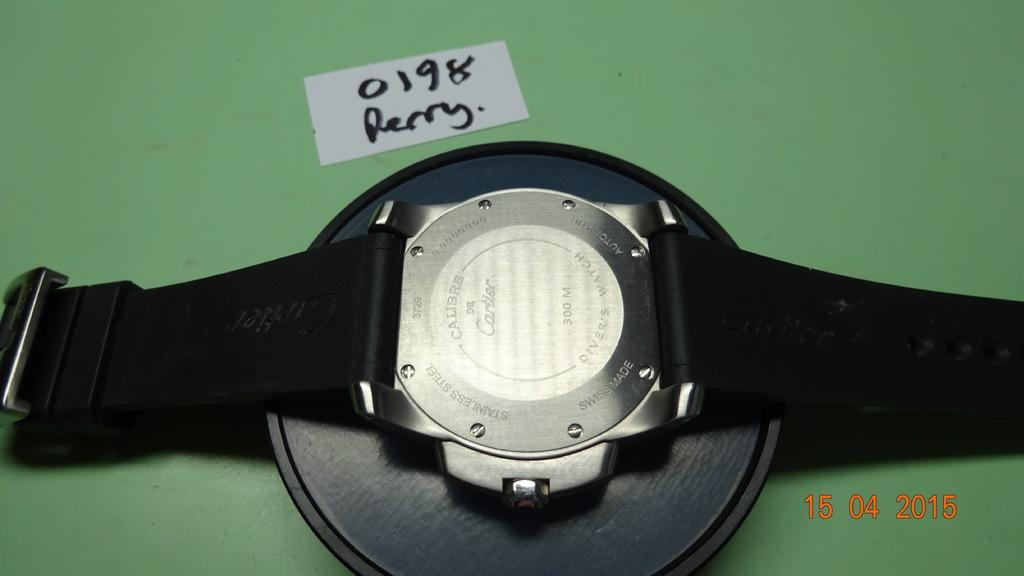<image>
Give a short and clear explanation of the subsequent image. The back of a Cartier watch says that it is for divers. 